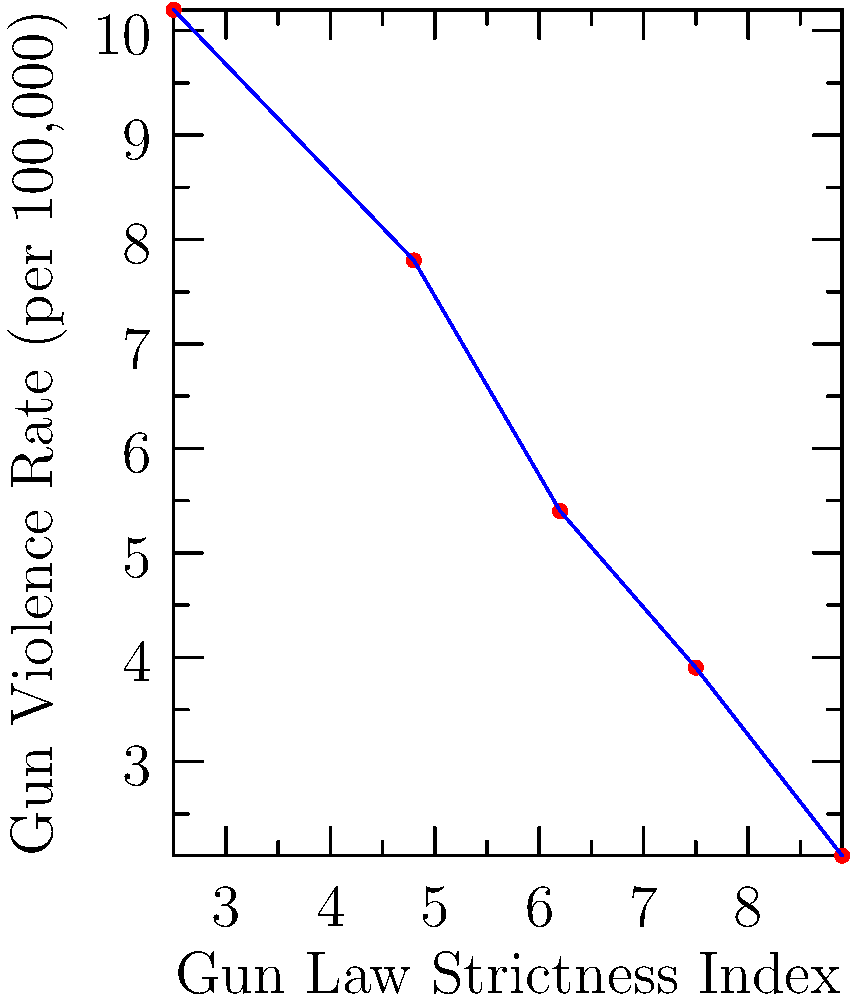Based on the scatter plot showing the relationship between gun law strictness and gun violence rates across different countries, what can be inferred about the effectiveness of stricter gun laws in reducing gun violence? How might this data challenge or support American gun policies? To analyze this scatter plot and draw conclusions:

1. Observe the overall trend: The plot shows a clear negative correlation between gun law strictness and gun violence rates.

2. Interpret the axes:
   - X-axis: Gun Law Strictness Index (higher values indicate stricter laws)
   - Y-axis: Gun Violence Rate per 100,000 population (higher values indicate more gun violence)

3. Analyze data points:
   - Countries with lower strictness indices (left side) have higher gun violence rates
   - Countries with higher strictness indices (right side) have lower gun violence rates

4. Calculate the correlation:
   - The line of best fit has a negative slope, indicating an inverse relationship
   - Rough estimation suggests a strong negative correlation (r ≈ -0.95)

5. Interpret the relationship:
   - As gun law strictness increases, gun violence rates tend to decrease
   - This suggests that stricter gun laws may be effective in reducing gun violence

6. Compare to American policies:
   - The US generally has less strict gun laws compared to many European countries
   - This data challenges the effectiveness of current American gun policies
   - It suggests that adopting stricter gun laws might lead to reduced gun violence in the US

7. Consider limitations:
   - Correlation does not imply causation
   - Other factors (e.g., cultural, socioeconomic) may influence gun violence rates
   - The sample size in this plot is small, and more comprehensive data would be needed for definitive conclusions

In conclusion, the data presents a strong case for the effectiveness of strict gun laws in reducing gun violence, which contradicts arguments often used to support lenient gun policies in the United States.
Answer: Stricter gun laws correlate with lower gun violence rates, challenging current US gun policies. 